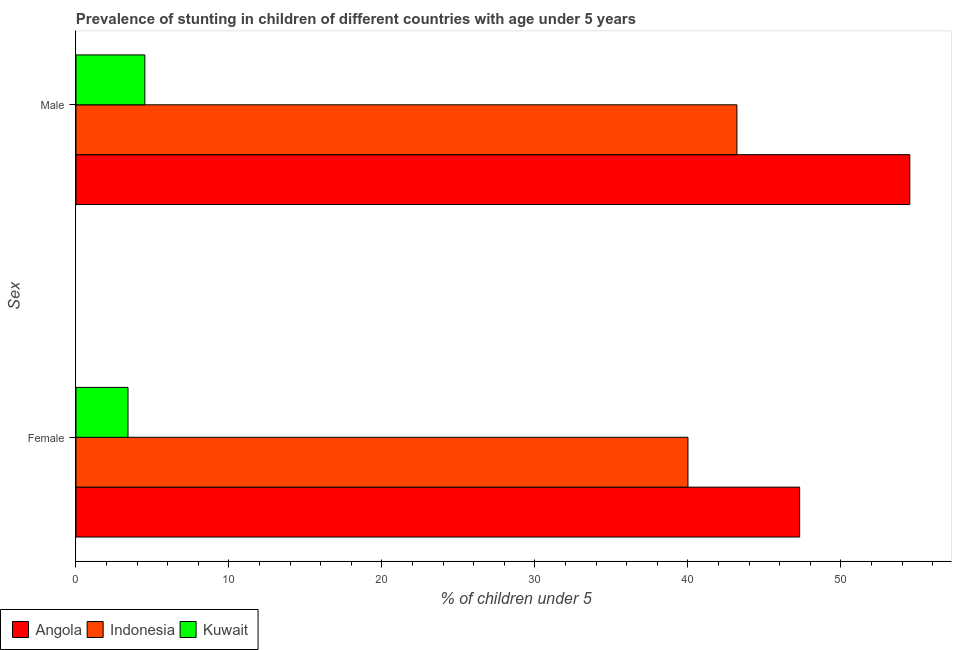How many different coloured bars are there?
Make the answer very short. 3. Are the number of bars on each tick of the Y-axis equal?
Offer a very short reply. Yes. What is the percentage of stunted male children in Indonesia?
Your answer should be very brief. 43.2. Across all countries, what is the maximum percentage of stunted female children?
Keep it short and to the point. 47.3. Across all countries, what is the minimum percentage of stunted male children?
Your answer should be very brief. 4.5. In which country was the percentage of stunted female children maximum?
Offer a terse response. Angola. In which country was the percentage of stunted female children minimum?
Make the answer very short. Kuwait. What is the total percentage of stunted female children in the graph?
Offer a very short reply. 90.7. What is the difference between the percentage of stunted female children in Angola and that in Indonesia?
Your answer should be very brief. 7.3. What is the difference between the percentage of stunted male children in Indonesia and the percentage of stunted female children in Angola?
Your response must be concise. -4.1. What is the average percentage of stunted female children per country?
Ensure brevity in your answer.  30.23. What is the difference between the percentage of stunted male children and percentage of stunted female children in Kuwait?
Give a very brief answer. 1.1. What is the ratio of the percentage of stunted female children in Kuwait to that in Indonesia?
Your response must be concise. 0.09. Is the percentage of stunted female children in Kuwait less than that in Angola?
Keep it short and to the point. Yes. What does the 1st bar from the top in Male represents?
Offer a terse response. Kuwait. What does the 3rd bar from the bottom in Male represents?
Offer a very short reply. Kuwait. How many bars are there?
Ensure brevity in your answer.  6. Are all the bars in the graph horizontal?
Make the answer very short. Yes. What is the title of the graph?
Your answer should be compact. Prevalence of stunting in children of different countries with age under 5 years. What is the label or title of the X-axis?
Offer a very short reply.  % of children under 5. What is the label or title of the Y-axis?
Make the answer very short. Sex. What is the  % of children under 5 of Angola in Female?
Your answer should be compact. 47.3. What is the  % of children under 5 in Indonesia in Female?
Make the answer very short. 40. What is the  % of children under 5 in Kuwait in Female?
Offer a very short reply. 3.4. What is the  % of children under 5 of Angola in Male?
Your response must be concise. 54.5. What is the  % of children under 5 in Indonesia in Male?
Offer a very short reply. 43.2. What is the  % of children under 5 in Kuwait in Male?
Ensure brevity in your answer.  4.5. Across all Sex, what is the maximum  % of children under 5 in Angola?
Your answer should be compact. 54.5. Across all Sex, what is the maximum  % of children under 5 of Indonesia?
Your answer should be compact. 43.2. Across all Sex, what is the maximum  % of children under 5 of Kuwait?
Make the answer very short. 4.5. Across all Sex, what is the minimum  % of children under 5 in Angola?
Provide a succinct answer. 47.3. Across all Sex, what is the minimum  % of children under 5 in Indonesia?
Provide a succinct answer. 40. Across all Sex, what is the minimum  % of children under 5 of Kuwait?
Your response must be concise. 3.4. What is the total  % of children under 5 in Angola in the graph?
Keep it short and to the point. 101.8. What is the total  % of children under 5 of Indonesia in the graph?
Your answer should be compact. 83.2. What is the difference between the  % of children under 5 of Indonesia in Female and that in Male?
Your answer should be very brief. -3.2. What is the difference between the  % of children under 5 of Angola in Female and the  % of children under 5 of Kuwait in Male?
Provide a short and direct response. 42.8. What is the difference between the  % of children under 5 in Indonesia in Female and the  % of children under 5 in Kuwait in Male?
Keep it short and to the point. 35.5. What is the average  % of children under 5 of Angola per Sex?
Offer a very short reply. 50.9. What is the average  % of children under 5 in Indonesia per Sex?
Your answer should be very brief. 41.6. What is the average  % of children under 5 of Kuwait per Sex?
Provide a succinct answer. 3.95. What is the difference between the  % of children under 5 in Angola and  % of children under 5 in Kuwait in Female?
Provide a succinct answer. 43.9. What is the difference between the  % of children under 5 in Indonesia and  % of children under 5 in Kuwait in Female?
Keep it short and to the point. 36.6. What is the difference between the  % of children under 5 in Angola and  % of children under 5 in Indonesia in Male?
Provide a succinct answer. 11.3. What is the difference between the  % of children under 5 in Angola and  % of children under 5 in Kuwait in Male?
Offer a very short reply. 50. What is the difference between the  % of children under 5 in Indonesia and  % of children under 5 in Kuwait in Male?
Provide a short and direct response. 38.7. What is the ratio of the  % of children under 5 in Angola in Female to that in Male?
Your answer should be compact. 0.87. What is the ratio of the  % of children under 5 in Indonesia in Female to that in Male?
Provide a short and direct response. 0.93. What is the ratio of the  % of children under 5 of Kuwait in Female to that in Male?
Your answer should be compact. 0.76. What is the difference between the highest and the lowest  % of children under 5 of Angola?
Your answer should be very brief. 7.2. What is the difference between the highest and the lowest  % of children under 5 of Indonesia?
Your answer should be compact. 3.2. What is the difference between the highest and the lowest  % of children under 5 in Kuwait?
Provide a short and direct response. 1.1. 